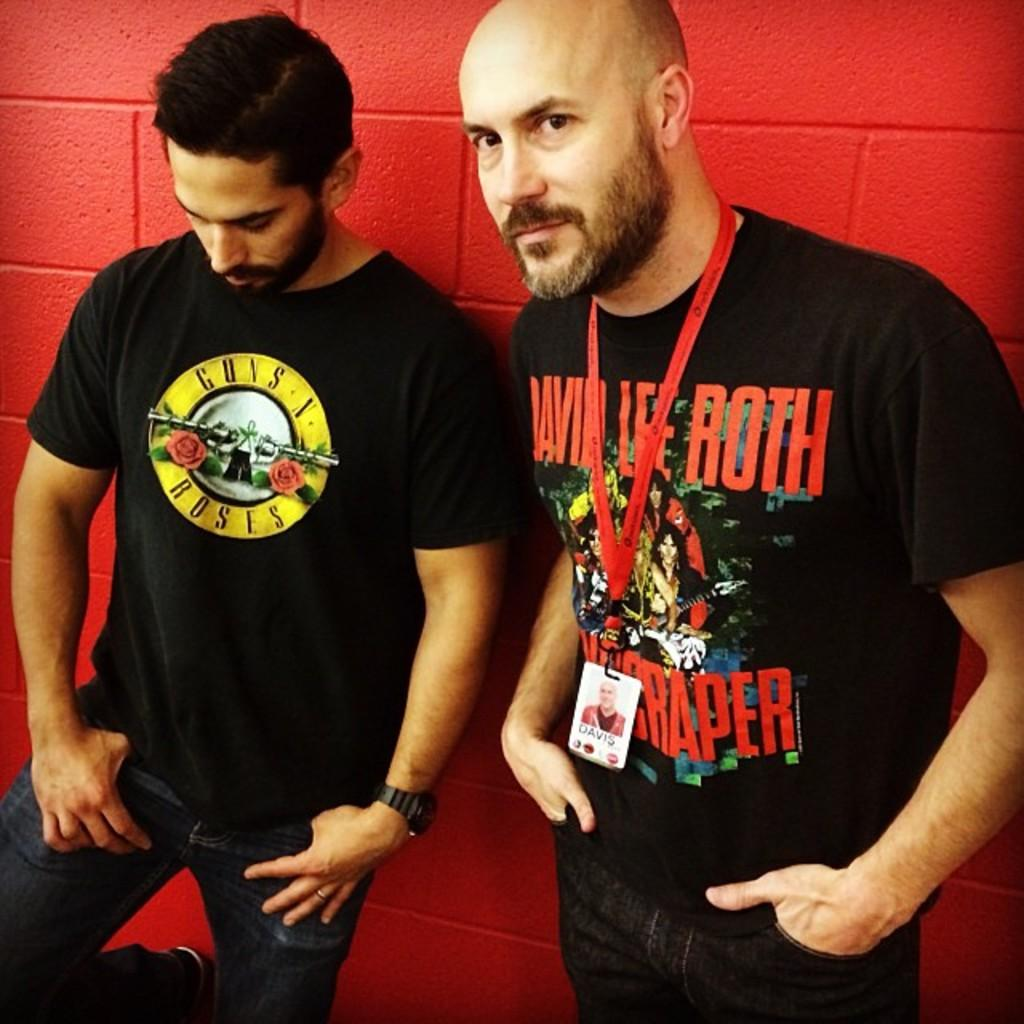Provide a one-sentence caption for the provided image. A man with a Guns N Roses t-shirt stand next to another man. 